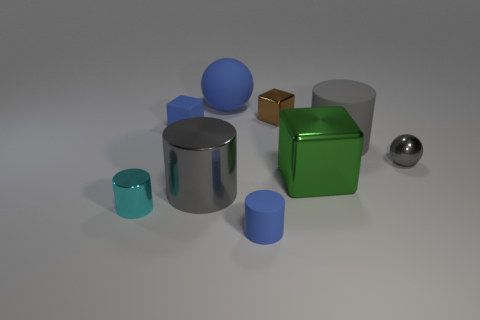Add 1 metal cylinders. How many objects exist? 10 Subtract all cubes. How many objects are left? 6 Add 9 matte spheres. How many matte spheres exist? 10 Subtract 0 red spheres. How many objects are left? 9 Subtract all small cyan metal things. Subtract all gray metal balls. How many objects are left? 7 Add 2 metallic cylinders. How many metallic cylinders are left? 4 